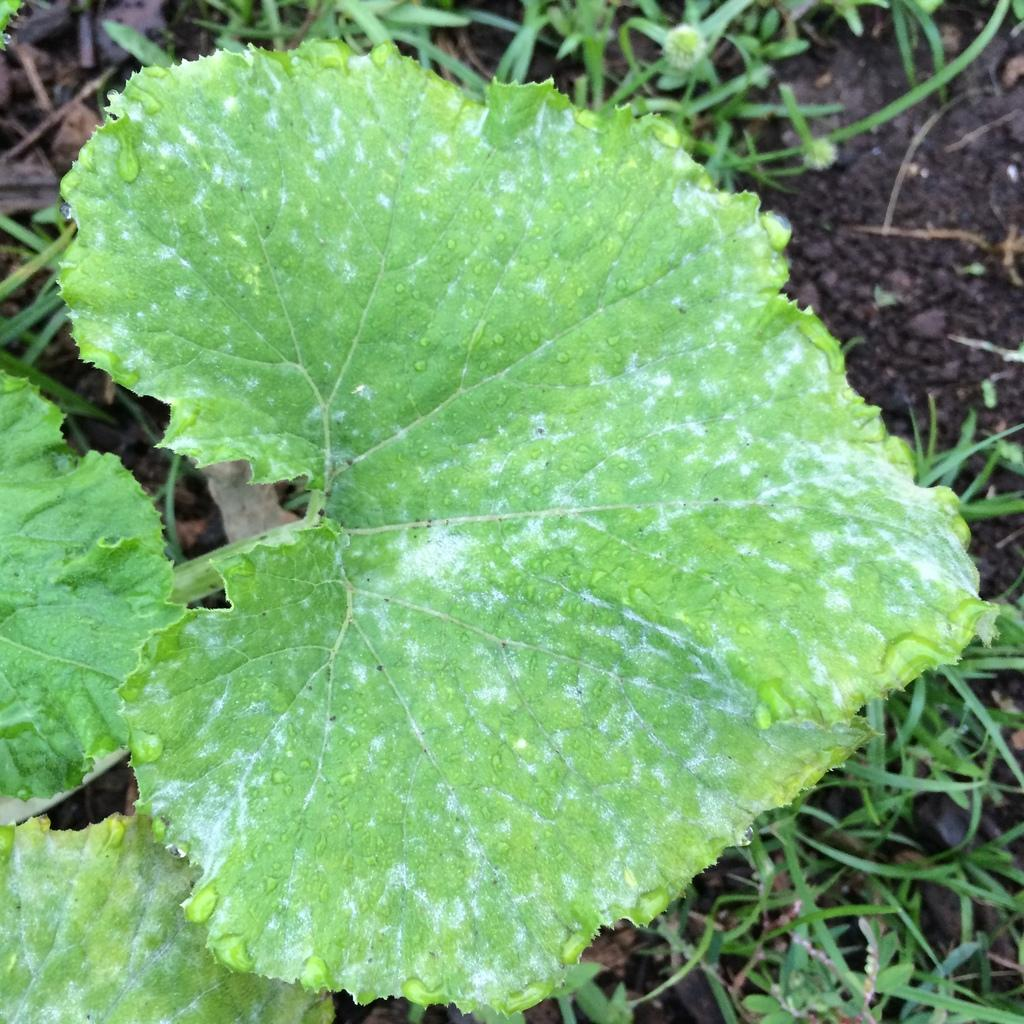What can be seen on the left side of the image? There are leaves with water droplets on the left side of the image. What is located beneath the leaves? There is soil visible below the leaves. What type of vegetation is present in the image? Grass is present on the soil. What type of coal can be seen in the image? There is no coal present in the image. What color is the tail of the animal in the image? There are no animals with tails present in the image. 